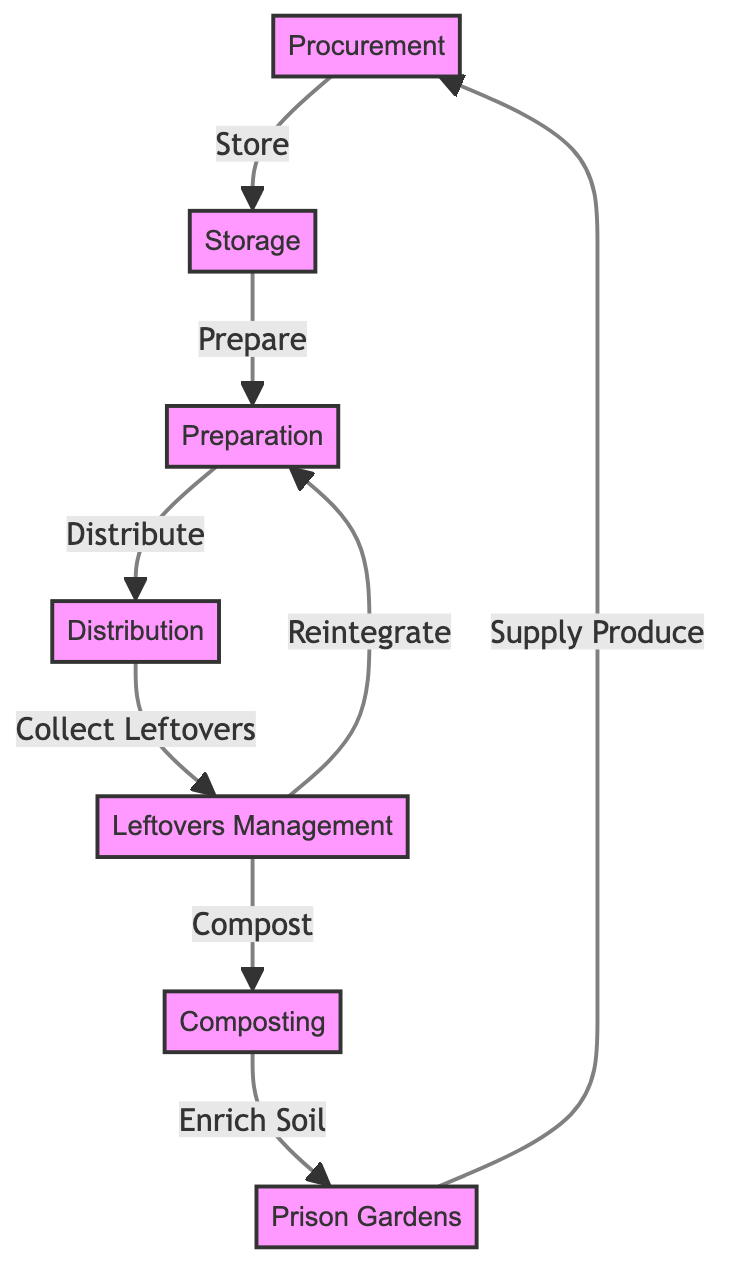What is the first node in the food chain? The first node, as represented in the diagram, is "Procurement." It is the starting point from which food supply management begins.
Answer: Procurement How many nodes are present in the diagram? By counting each distinct node depicted in the diagram, there are a total of seven nodes: Procurement, Storage, Preparation, Distribution, Leftovers Management, Composting, and Prison Gardens.
Answer: 7 What connects Storage to Preparation in the diagram? The connection from Storage to Preparation is labeled as "Prepare," indicating the action that occurs between these two nodes in the food chain.
Answer: Prepare Which node does Leftovers Management lead to in two different ways? The Leftovers Management node has two outputs: it leads back to Preparation and also directs to Composting, illustrating the dual outcomes of managing leftovers.
Answer: Preparation and Composting What is the last node in the food chain? The last node in the diagram is "Prison Gardens," which indicates the endpoint where the collected compost is utilized to enrich the soil for growing produce.
Answer: Prison Gardens What flows from Composting to Prison Gardens? The connection from Composting to Prison Gardens is labeled "Enrich Soil," showing the process of enhancing the soil with compost produced from leftovers.
Answer: Enrich Soil How many relationships are there in total between the nodes? By totaling the directed edges connecting the nodes, there are a total of seven relationships shown in the food chain diagram, illustrating the flow of processes.
Answer: 7 What is the action performed between Distribution and Leftovers Management? The action represented between Distribution and Leftovers Management is labeled "Collect Leftovers," indicating what occurs at that stage of the food chain.
Answer: Collect Leftovers What is the purpose of the Prison Gardens in the food chain? The purpose of the Prison Gardens, as illustrated in the diagram, is to "Supply Produce," serving as a sustainable way to use the enriched soil from the composting process.
Answer: Supply Produce 